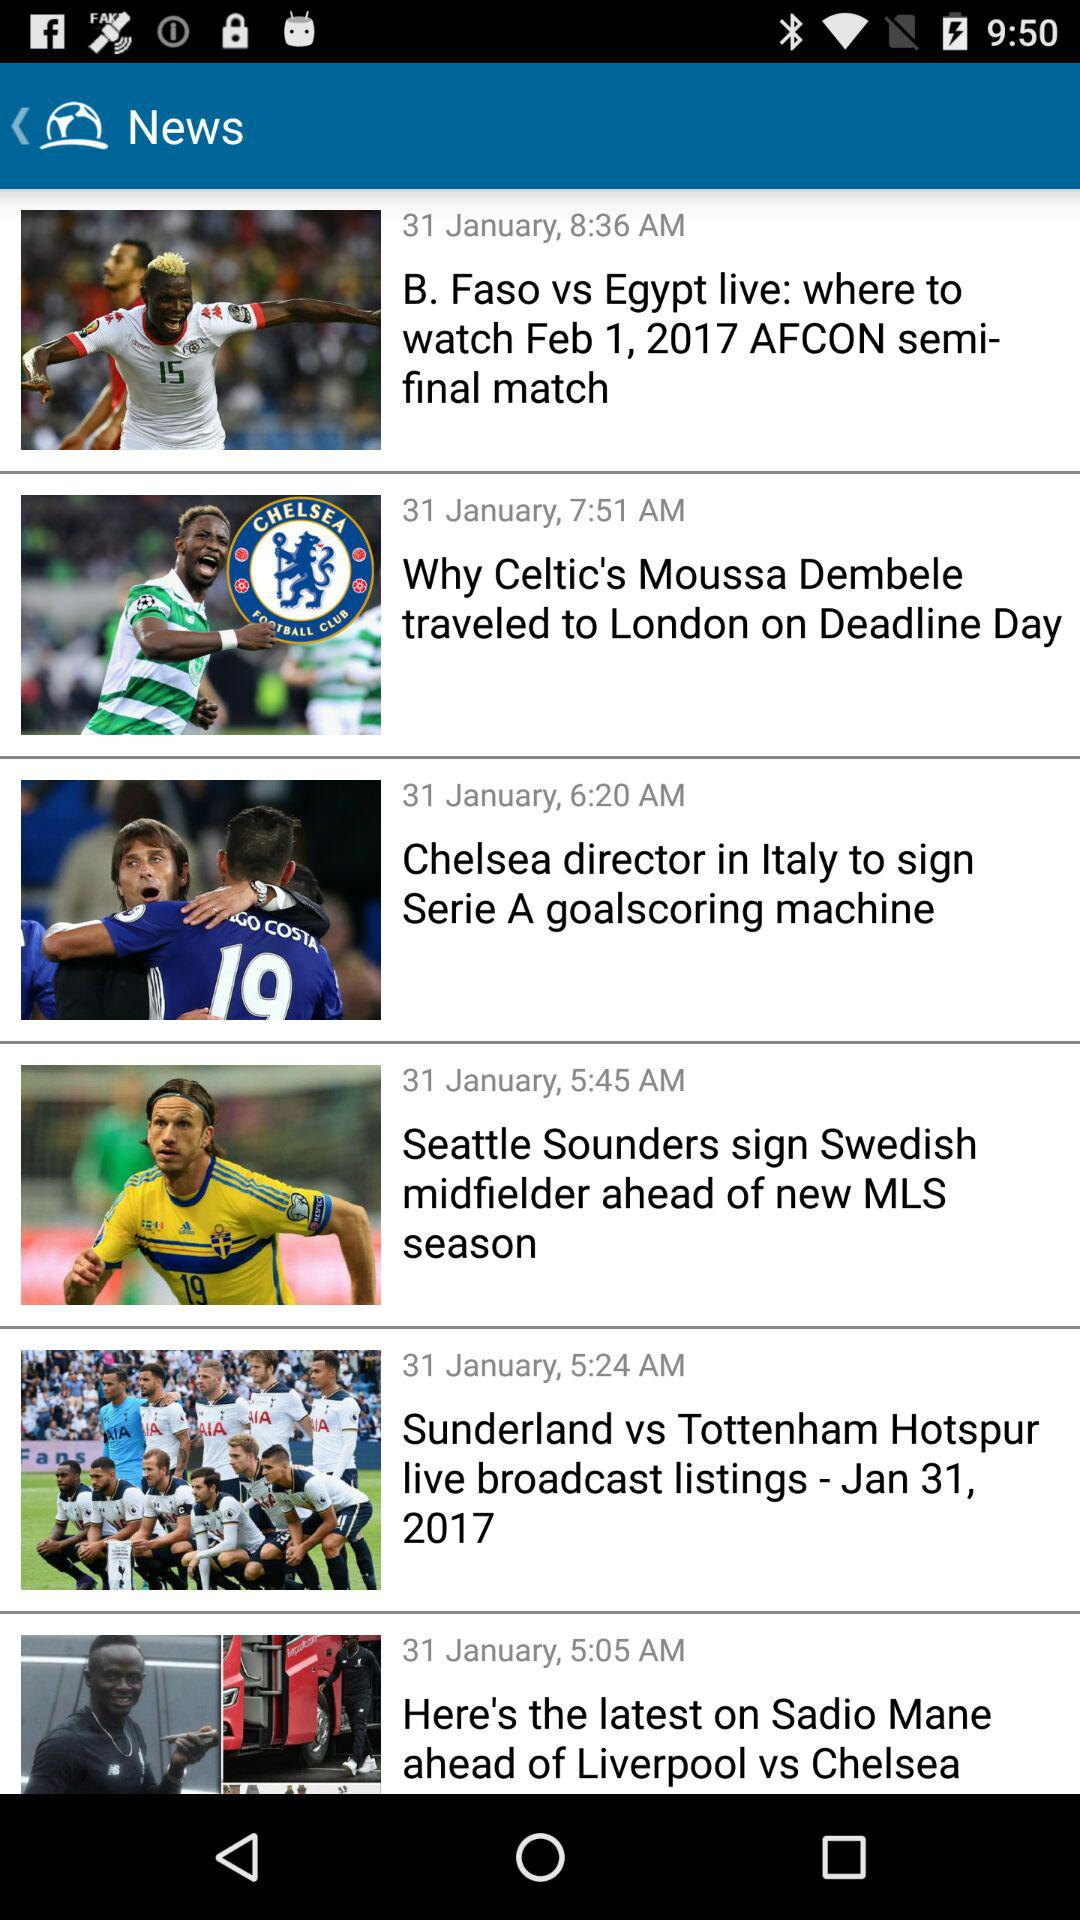What is the posted date and time of the "Sunderland vs Tottenham Hotspur live broadcast listings"? The posted date and time are January 31 and 5:24 AM, respectively. 